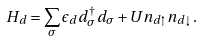<formula> <loc_0><loc_0><loc_500><loc_500>H _ { d } = \sum _ { \sigma } \epsilon _ { d } d ^ { \dagger } _ { \sigma } d _ { \sigma } + U n _ { d \uparrow } n _ { d \downarrow } \, .</formula> 